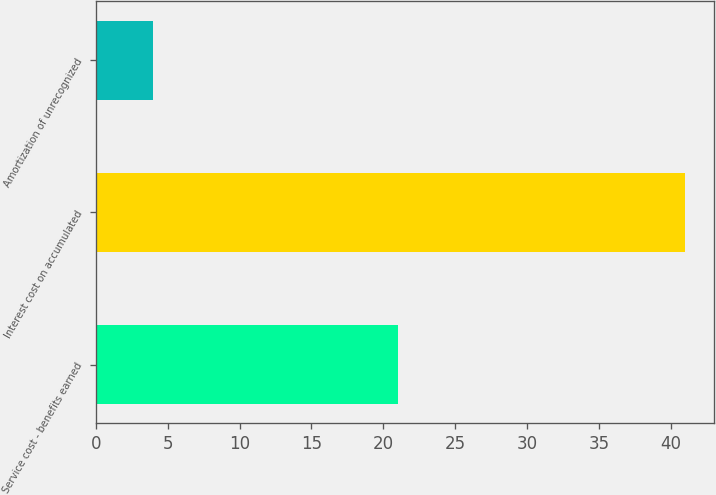<chart> <loc_0><loc_0><loc_500><loc_500><bar_chart><fcel>Service cost - benefits earned<fcel>Interest cost on accumulated<fcel>Amortization of unrecognized<nl><fcel>21<fcel>41<fcel>4<nl></chart> 